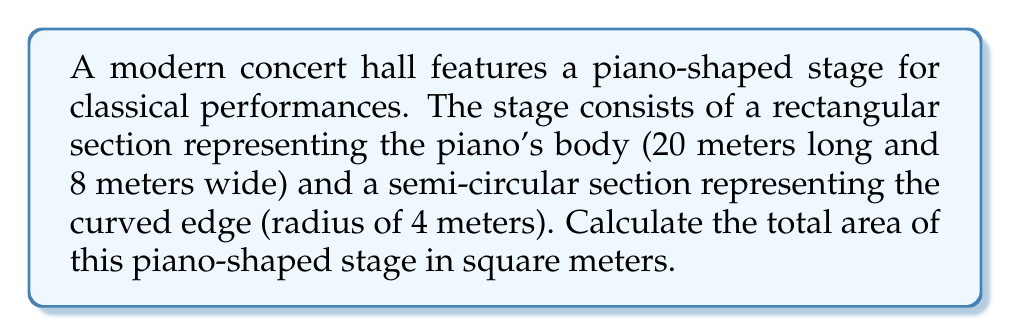Can you answer this question? To calculate the area of the piano-shaped stage, we need to break it down into composite shapes:

1. Rectangular section (piano body):
   Area of rectangle = length × width
   $A_r = 20\text{ m} \times 8\text{ m} = 160\text{ m}^2$

2. Semi-circular section (curved edge):
   Area of semi-circle = $\frac{1}{2} \times \pi r^2$
   $A_s = \frac{1}{2} \times \pi \times (4\text{ m})^2 = 8\pi\text{ m}^2$

3. Total area:
   $A_{\text{total}} = A_r + A_s = 160\text{ m}^2 + 8\pi\text{ m}^2$

4. Simplify:
   $A_{\text{total}} = 160 + 8\pi\text{ m}^2 \approx 185.13\text{ m}^2$

[asy]
unitsize(5mm);
fill((0,0)--(20,0)--(20,8)--(0,8)--cycle,lightgray);
fill(arc((20,4),4,270,90),lightgray);
draw((0,0)--(20,0)--(20,8)--(0,8)--cycle);
draw(arc((20,4),4,270,90));
label("20 m", (10,-1), S);
label("8 m", (-1,4), W);
label("r = 4 m", (22,4), E);
[/asy]
Answer: $185.13\text{ m}^2$ 